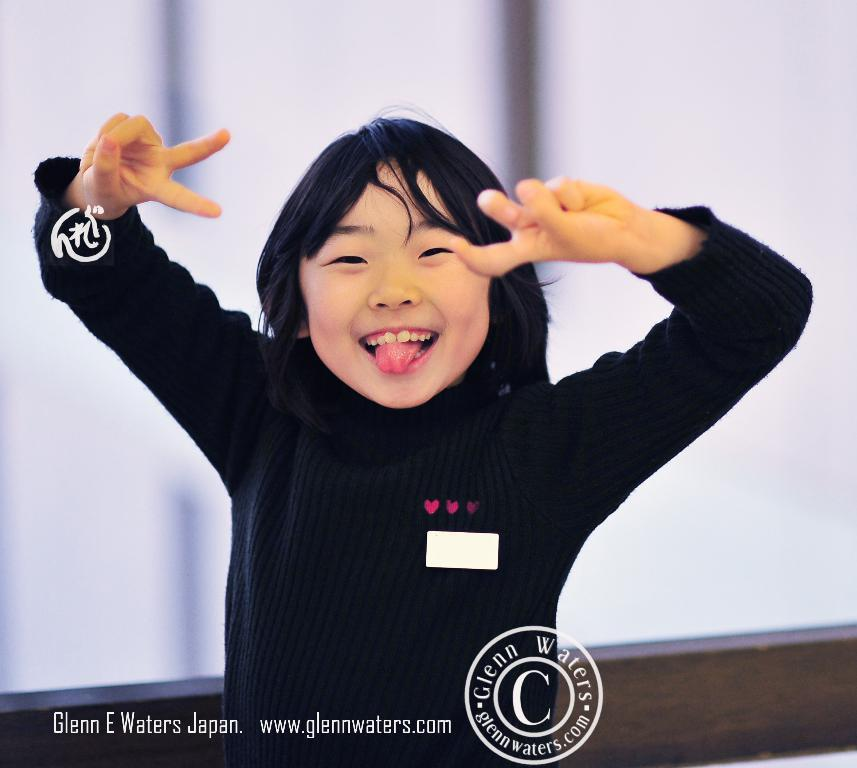Who is present in the image? There is a girl in the image. What is the girl's expression in the image? The girl is smiling in the image. What can be found at the bottom of the image? There is text written at the bottom of the image. What brand or organization might be associated with the image? There is a logo in the image, which could be associated with a brand or organization. How is the background behind the girl depicted? The background behind the girl is blurred in the image. Are there any giants visible in the image? No, there are no giants present in the image. What park is the girl playing in, as seen in the image? The image does not show the girl in a park, nor does it depict any park-related elements. 